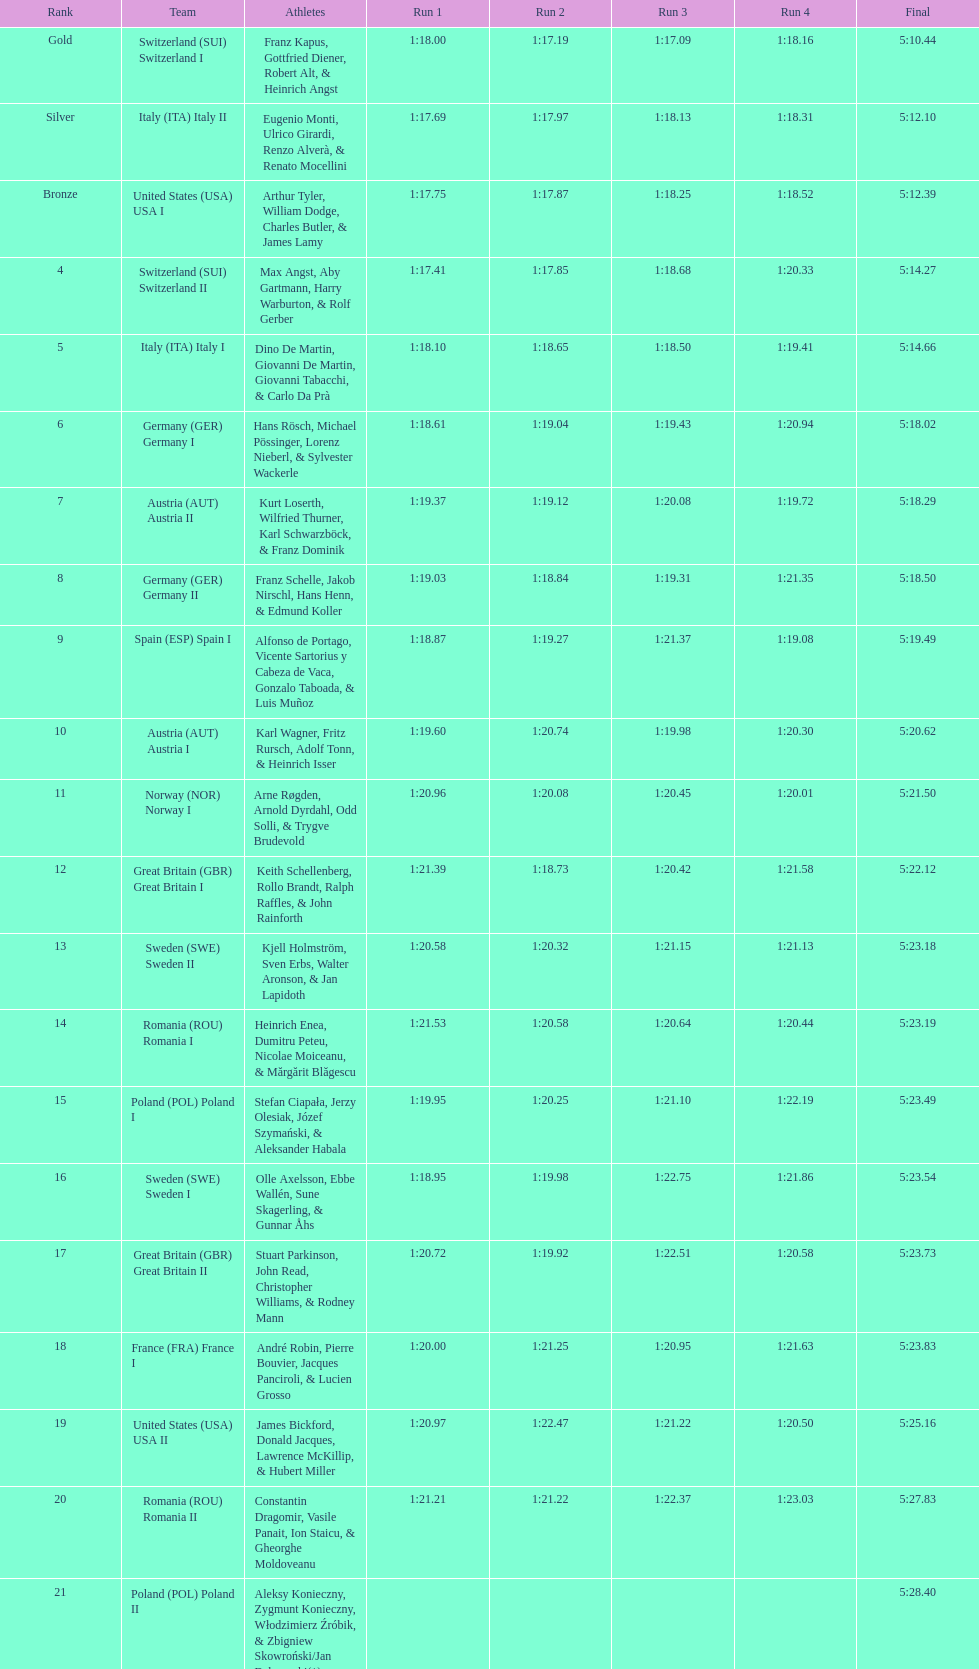Would you mind parsing the complete table? {'header': ['Rank', 'Team', 'Athletes', 'Run 1', 'Run 2', 'Run 3', 'Run 4', 'Final'], 'rows': [['Gold', 'Switzerland\xa0(SUI) Switzerland I', 'Franz Kapus, Gottfried Diener, Robert Alt, & Heinrich Angst', '1:18.00', '1:17.19', '1:17.09', '1:18.16', '5:10.44'], ['Silver', 'Italy\xa0(ITA) Italy II', 'Eugenio Monti, Ulrico Girardi, Renzo Alverà, & Renato Mocellini', '1:17.69', '1:17.97', '1:18.13', '1:18.31', '5:12.10'], ['Bronze', 'United States\xa0(USA) USA I', 'Arthur Tyler, William Dodge, Charles Butler, & James Lamy', '1:17.75', '1:17.87', '1:18.25', '1:18.52', '5:12.39'], ['4', 'Switzerland\xa0(SUI) Switzerland II', 'Max Angst, Aby Gartmann, Harry Warburton, & Rolf Gerber', '1:17.41', '1:17.85', '1:18.68', '1:20.33', '5:14.27'], ['5', 'Italy\xa0(ITA) Italy I', 'Dino De Martin, Giovanni De Martin, Giovanni Tabacchi, & Carlo Da Prà', '1:18.10', '1:18.65', '1:18.50', '1:19.41', '5:14.66'], ['6', 'Germany\xa0(GER) Germany I', 'Hans Rösch, Michael Pössinger, Lorenz Nieberl, & Sylvester Wackerle', '1:18.61', '1:19.04', '1:19.43', '1:20.94', '5:18.02'], ['7', 'Austria\xa0(AUT) Austria II', 'Kurt Loserth, Wilfried Thurner, Karl Schwarzböck, & Franz Dominik', '1:19.37', '1:19.12', '1:20.08', '1:19.72', '5:18.29'], ['8', 'Germany\xa0(GER) Germany II', 'Franz Schelle, Jakob Nirschl, Hans Henn, & Edmund Koller', '1:19.03', '1:18.84', '1:19.31', '1:21.35', '5:18.50'], ['9', 'Spain\xa0(ESP) Spain I', 'Alfonso de Portago, Vicente Sartorius y Cabeza de Vaca, Gonzalo Taboada, & Luis Muñoz', '1:18.87', '1:19.27', '1:21.37', '1:19.08', '5:19.49'], ['10', 'Austria\xa0(AUT) Austria I', 'Karl Wagner, Fritz Rursch, Adolf Tonn, & Heinrich Isser', '1:19.60', '1:20.74', '1:19.98', '1:20.30', '5:20.62'], ['11', 'Norway\xa0(NOR) Norway I', 'Arne Røgden, Arnold Dyrdahl, Odd Solli, & Trygve Brudevold', '1:20.96', '1:20.08', '1:20.45', '1:20.01', '5:21.50'], ['12', 'Great Britain\xa0(GBR) Great Britain I', 'Keith Schellenberg, Rollo Brandt, Ralph Raffles, & John Rainforth', '1:21.39', '1:18.73', '1:20.42', '1:21.58', '5:22.12'], ['13', 'Sweden\xa0(SWE) Sweden II', 'Kjell Holmström, Sven Erbs, Walter Aronson, & Jan Lapidoth', '1:20.58', '1:20.32', '1:21.15', '1:21.13', '5:23.18'], ['14', 'Romania\xa0(ROU) Romania I', 'Heinrich Enea, Dumitru Peteu, Nicolae Moiceanu, & Mărgărit Blăgescu', '1:21.53', '1:20.58', '1:20.64', '1:20.44', '5:23.19'], ['15', 'Poland\xa0(POL) Poland I', 'Stefan Ciapała, Jerzy Olesiak, Józef Szymański, & Aleksander Habala', '1:19.95', '1:20.25', '1:21.10', '1:22.19', '5:23.49'], ['16', 'Sweden\xa0(SWE) Sweden I', 'Olle Axelsson, Ebbe Wallén, Sune Skagerling, & Gunnar Åhs', '1:18.95', '1:19.98', '1:22.75', '1:21.86', '5:23.54'], ['17', 'Great Britain\xa0(GBR) Great Britain II', 'Stuart Parkinson, John Read, Christopher Williams, & Rodney Mann', '1:20.72', '1:19.92', '1:22.51', '1:20.58', '5:23.73'], ['18', 'France\xa0(FRA) France I', 'André Robin, Pierre Bouvier, Jacques Panciroli, & Lucien Grosso', '1:20.00', '1:21.25', '1:20.95', '1:21.63', '5:23.83'], ['19', 'United States\xa0(USA) USA II', 'James Bickford, Donald Jacques, Lawrence McKillip, & Hubert Miller', '1:20.97', '1:22.47', '1:21.22', '1:20.50', '5:25.16'], ['20', 'Romania\xa0(ROU) Romania II', 'Constantin Dragomir, Vasile Panait, Ion Staicu, & Gheorghe Moldoveanu', '1:21.21', '1:21.22', '1:22.37', '1:23.03', '5:27.83'], ['21', 'Poland\xa0(POL) Poland II', 'Aleksy Konieczny, Zygmunt Konieczny, Włodzimierz Źróbik, & Zbigniew Skowroński/Jan Dąbrowski(*)', '', '', '', '', '5:28.40']]} Name a country that had 4 consecutive runs under 1:19. Switzerland. 